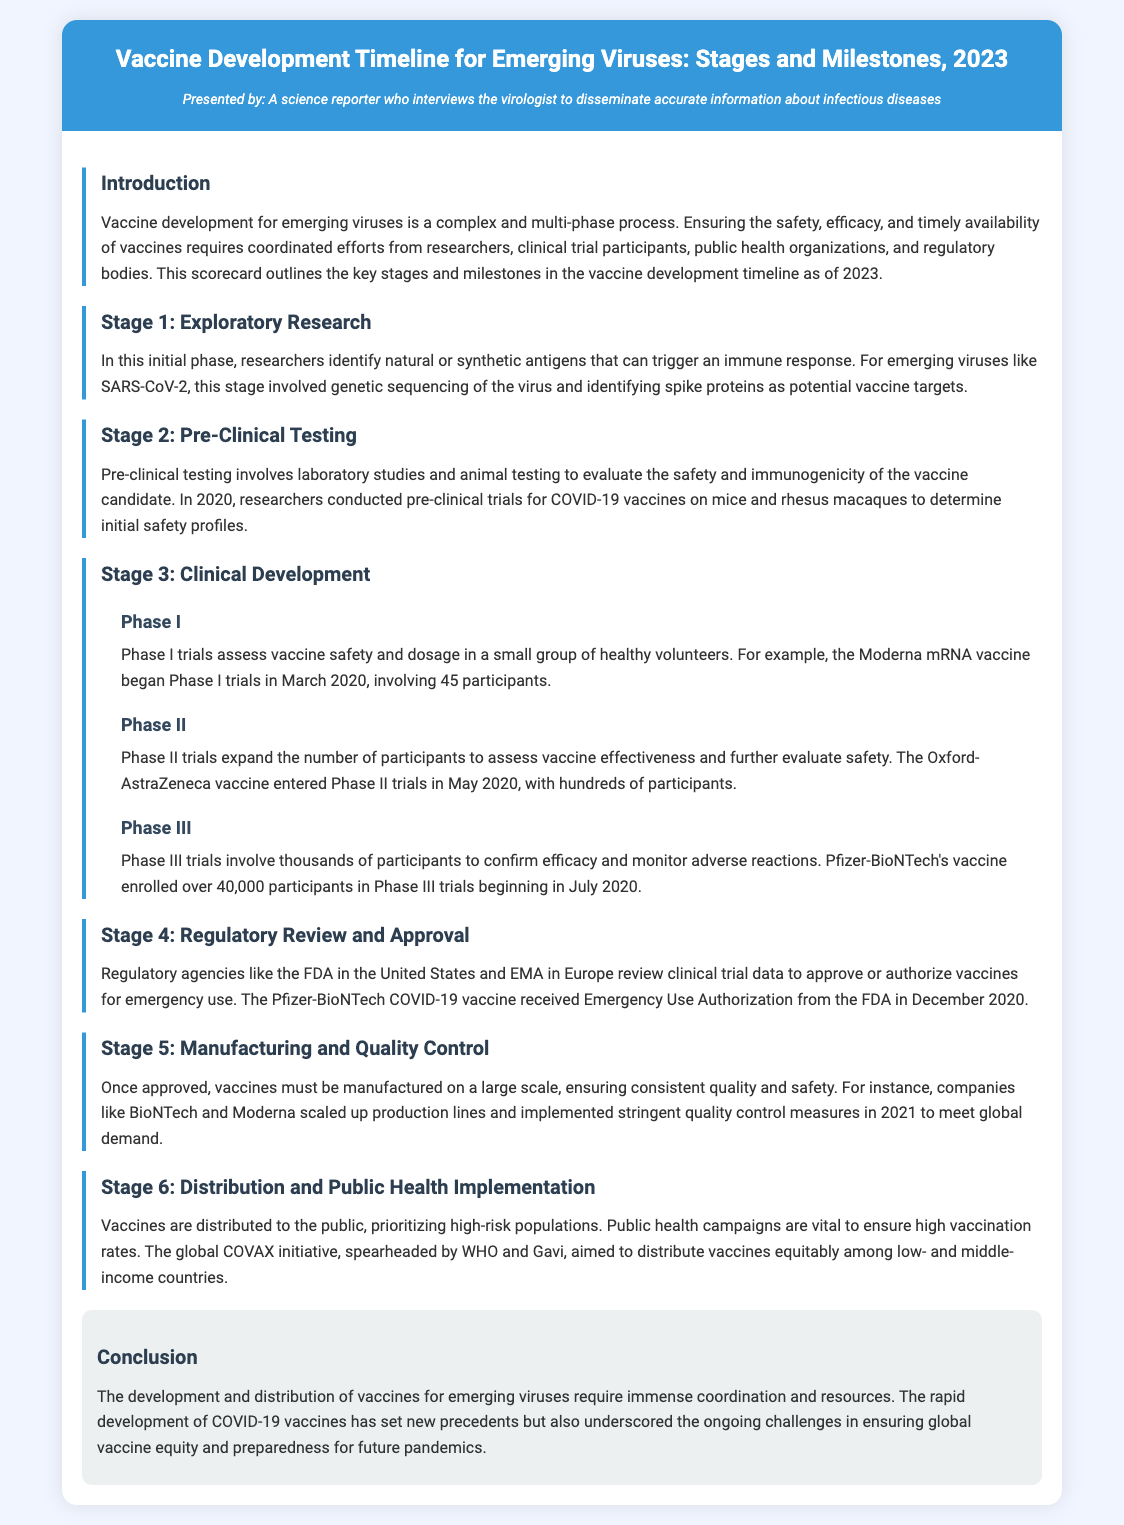What is the title of the document? The title of the document is indicated in the header section, which outlines the main focus on vaccine development timelines for emerging viruses.
Answer: Vaccine Development Timeline for Emerging Viruses: Stages and Milestones, 2023 What phase involves laboratory studies and animal testing? In the scorecard, the phase that involves laboratory studies and animal testing is labeled clearly as part of the pre-clinical testing stage.
Answer: Pre-Clinical Testing How many participants were involved in the Moderna Phase I trials? The document specifies the exact number of participants involved in the Phase I trials for the Moderna vaccine during the clinical development stage.
Answer: 45 Which vaccine received Emergency Use Authorization in December 2020? The document explicitly states that the Pfizer-BioNTech COVID-19 vaccine is the one that received Emergency Use Authorization from the FDA in December 2020.
Answer: Pfizer-BioNTech What is the main aim of the global COVAX initiative? The COVAX initiative's goal, as described in the document, focuses on equitable distribution of vaccines among populations.
Answer: Distribute vaccines equitably What stage involves assessing vaccine effectiveness and further evaluating safety? The document provides a description of different phases of clinical development, highlighting which specific phase is concerned with safety and effectiveness evaluation.
Answer: Phase II During which year did the Oxford-AstraZeneca vaccine enter Phase II trials? The document provides a timeline indicating when the Oxford-AstraZeneca vaccine began its Phase II trials, specifically referring to a date.
Answer: May 2020 What is highlighted as a challenge in the conclusion? The conclusion summarizes the overarching issues faced in ensuring the development and distribution of vaccines, particularly emphasizing a key challenge.
Answer: Global vaccine equity Which stage immediately follows regulatory review and approval? Based on the structure of the document, the stage that follows regulatory review is clearly outlined to signify what comes next.
Answer: Manufacturing and Quality Control 